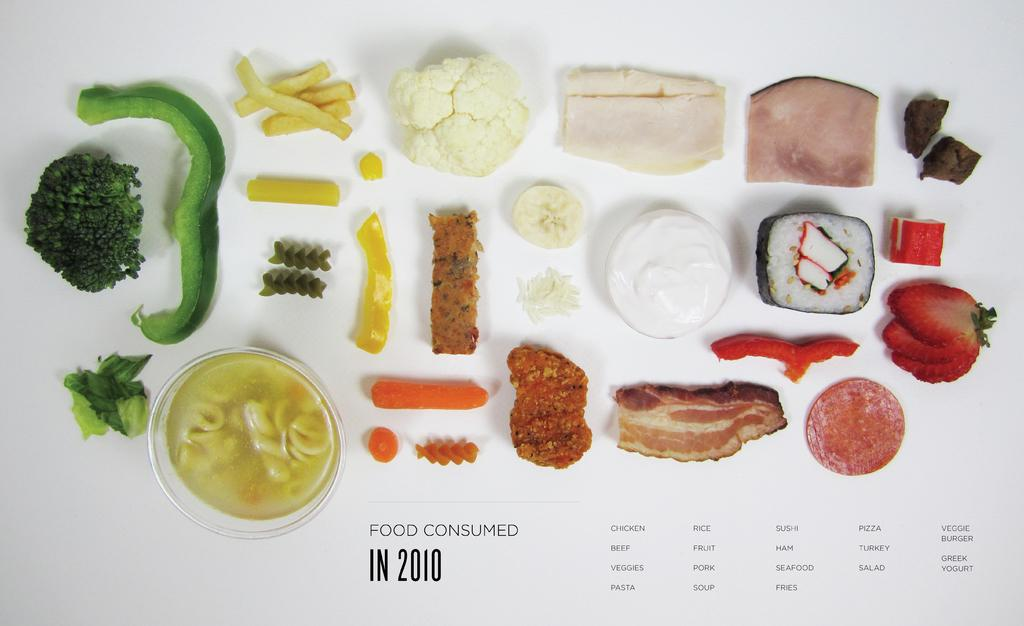What types of food can be seen in the image? The image contains different vegetables, fruits, and meat. Can you describe the variety of food items in the image? The image contains a variety of vegetables, fruits, and meat, including examples of each category. Where was the image taken from? The image was taken from a website. What type of roof can be seen on the boats in the image? There are no boats or roofs present in the image; it contains different vegetables, fruits, and meat. 